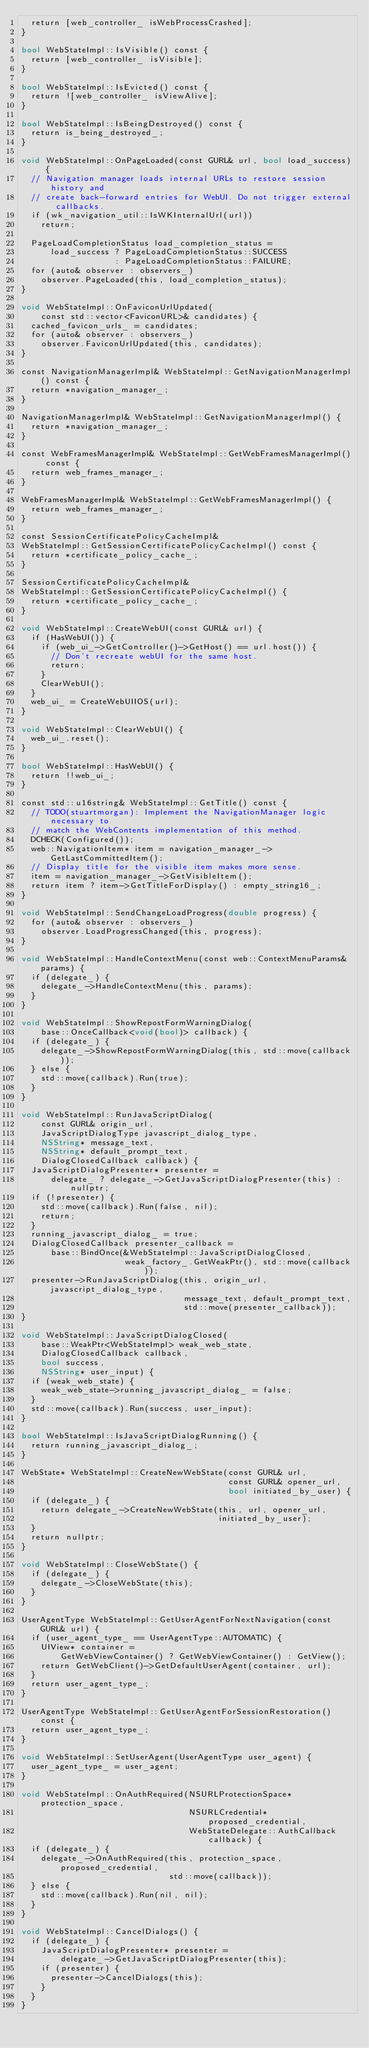<code> <loc_0><loc_0><loc_500><loc_500><_ObjectiveC_>  return [web_controller_ isWebProcessCrashed];
}

bool WebStateImpl::IsVisible() const {
  return [web_controller_ isVisible];
}

bool WebStateImpl::IsEvicted() const {
  return ![web_controller_ isViewAlive];
}

bool WebStateImpl::IsBeingDestroyed() const {
  return is_being_destroyed_;
}

void WebStateImpl::OnPageLoaded(const GURL& url, bool load_success) {
  // Navigation manager loads internal URLs to restore session history and
  // create back-forward entries for WebUI. Do not trigger external callbacks.
  if (wk_navigation_util::IsWKInternalUrl(url))
    return;

  PageLoadCompletionStatus load_completion_status =
      load_success ? PageLoadCompletionStatus::SUCCESS
                   : PageLoadCompletionStatus::FAILURE;
  for (auto& observer : observers_)
    observer.PageLoaded(this, load_completion_status);
}

void WebStateImpl::OnFaviconUrlUpdated(
    const std::vector<FaviconURL>& candidates) {
  cached_favicon_urls_ = candidates;
  for (auto& observer : observers_)
    observer.FaviconUrlUpdated(this, candidates);
}

const NavigationManagerImpl& WebStateImpl::GetNavigationManagerImpl() const {
  return *navigation_manager_;
}

NavigationManagerImpl& WebStateImpl::GetNavigationManagerImpl() {
  return *navigation_manager_;
}

const WebFramesManagerImpl& WebStateImpl::GetWebFramesManagerImpl() const {
  return web_frames_manager_;
}

WebFramesManagerImpl& WebStateImpl::GetWebFramesManagerImpl() {
  return web_frames_manager_;
}

const SessionCertificatePolicyCacheImpl&
WebStateImpl::GetSessionCertificatePolicyCacheImpl() const {
  return *certificate_policy_cache_;
}

SessionCertificatePolicyCacheImpl&
WebStateImpl::GetSessionCertificatePolicyCacheImpl() {
  return *certificate_policy_cache_;
}

void WebStateImpl::CreateWebUI(const GURL& url) {
  if (HasWebUI()) {
    if (web_ui_->GetController()->GetHost() == url.host()) {
      // Don't recreate webUI for the same host.
      return;
    }
    ClearWebUI();
  }
  web_ui_ = CreateWebUIIOS(url);
}

void WebStateImpl::ClearWebUI() {
  web_ui_.reset();
}

bool WebStateImpl::HasWebUI() {
  return !!web_ui_;
}

const std::u16string& WebStateImpl::GetTitle() const {
  // TODO(stuartmorgan): Implement the NavigationManager logic necessary to
  // match the WebContents implementation of this method.
  DCHECK(Configured());
  web::NavigationItem* item = navigation_manager_->GetLastCommittedItem();
  // Display title for the visible item makes more sense.
  item = navigation_manager_->GetVisibleItem();
  return item ? item->GetTitleForDisplay() : empty_string16_;
}

void WebStateImpl::SendChangeLoadProgress(double progress) {
  for (auto& observer : observers_)
    observer.LoadProgressChanged(this, progress);
}

void WebStateImpl::HandleContextMenu(const web::ContextMenuParams& params) {
  if (delegate_) {
    delegate_->HandleContextMenu(this, params);
  }
}

void WebStateImpl::ShowRepostFormWarningDialog(
    base::OnceCallback<void(bool)> callback) {
  if (delegate_) {
    delegate_->ShowRepostFormWarningDialog(this, std::move(callback));
  } else {
    std::move(callback).Run(true);
  }
}

void WebStateImpl::RunJavaScriptDialog(
    const GURL& origin_url,
    JavaScriptDialogType javascript_dialog_type,
    NSString* message_text,
    NSString* default_prompt_text,
    DialogClosedCallback callback) {
  JavaScriptDialogPresenter* presenter =
      delegate_ ? delegate_->GetJavaScriptDialogPresenter(this) : nullptr;
  if (!presenter) {
    std::move(callback).Run(false, nil);
    return;
  }
  running_javascript_dialog_ = true;
  DialogClosedCallback presenter_callback =
      base::BindOnce(&WebStateImpl::JavaScriptDialogClosed,
                     weak_factory_.GetWeakPtr(), std::move(callback));
  presenter->RunJavaScriptDialog(this, origin_url, javascript_dialog_type,
                                 message_text, default_prompt_text,
                                 std::move(presenter_callback));
}

void WebStateImpl::JavaScriptDialogClosed(
    base::WeakPtr<WebStateImpl> weak_web_state,
    DialogClosedCallback callback,
    bool success,
    NSString* user_input) {
  if (weak_web_state) {
    weak_web_state->running_javascript_dialog_ = false;
  }
  std::move(callback).Run(success, user_input);
}

bool WebStateImpl::IsJavaScriptDialogRunning() {
  return running_javascript_dialog_;
}

WebState* WebStateImpl::CreateNewWebState(const GURL& url,
                                          const GURL& opener_url,
                                          bool initiated_by_user) {
  if (delegate_) {
    return delegate_->CreateNewWebState(this, url, opener_url,
                                        initiated_by_user);
  }
  return nullptr;
}

void WebStateImpl::CloseWebState() {
  if (delegate_) {
    delegate_->CloseWebState(this);
  }
}

UserAgentType WebStateImpl::GetUserAgentForNextNavigation(const GURL& url) {
  if (user_agent_type_ == UserAgentType::AUTOMATIC) {
    UIView* container =
        GetWebViewContainer() ? GetWebViewContainer() : GetView();
    return GetWebClient()->GetDefaultUserAgent(container, url);
  }
  return user_agent_type_;
}

UserAgentType WebStateImpl::GetUserAgentForSessionRestoration() const {
  return user_agent_type_;
}

void WebStateImpl::SetUserAgent(UserAgentType user_agent) {
  user_agent_type_ = user_agent;
}

void WebStateImpl::OnAuthRequired(NSURLProtectionSpace* protection_space,
                                  NSURLCredential* proposed_credential,
                                  WebStateDelegate::AuthCallback callback) {
  if (delegate_) {
    delegate_->OnAuthRequired(this, protection_space, proposed_credential,
                              std::move(callback));
  } else {
    std::move(callback).Run(nil, nil);
  }
}

void WebStateImpl::CancelDialogs() {
  if (delegate_) {
    JavaScriptDialogPresenter* presenter =
        delegate_->GetJavaScriptDialogPresenter(this);
    if (presenter) {
      presenter->CancelDialogs(this);
    }
  }
}
</code> 